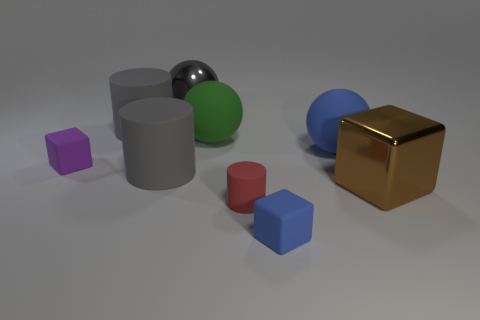How many gray cylinders must be subtracted to get 1 gray cylinders? 1 Subtract all cylinders. How many objects are left? 6 Subtract all red things. Subtract all rubber cubes. How many objects are left? 6 Add 6 large brown shiny things. How many large brown shiny things are left? 7 Add 5 small purple blocks. How many small purple blocks exist? 6 Subtract 1 gray balls. How many objects are left? 8 